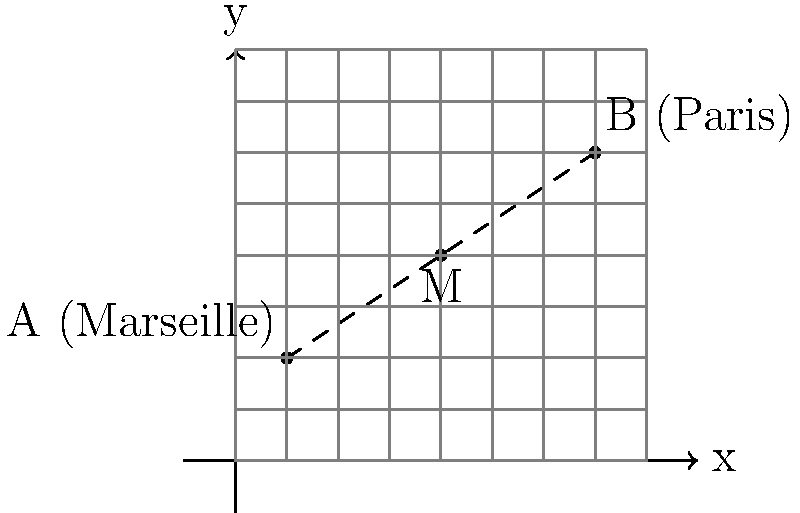On a coordinate plane representing a map of France, the hometown of Zinedine Zidane (Marseille) is located at point A(1, 2), while the hometown of Kylian Mbappé (Paris) is at point B(7, 6). Find the coordinates of point M, which represents the midpoint between these two cities. To find the midpoint between two points, we use the midpoint formula:

$$ M_x = \frac{x_1 + x_2}{2}, M_y = \frac{y_1 + y_2}{2} $$

Where $(x_1, y_1)$ are the coordinates of point A and $(x_2, y_2)$ are the coordinates of point B.

Step 1: Identify the coordinates
A (Marseille): (1, 2)
B (Paris): (7, 6)

Step 2: Calculate the x-coordinate of the midpoint
$$ M_x = \frac{x_1 + x_2}{2} = \frac{1 + 7}{2} = \frac{8}{2} = 4 $$

Step 3: Calculate the y-coordinate of the midpoint
$$ M_y = \frac{y_1 + y_2}{2} = \frac{2 + 6}{2} = \frac{8}{2} = 4 $$

Step 4: Combine the results
The midpoint M has coordinates (4, 4).
Answer: (4, 4) 